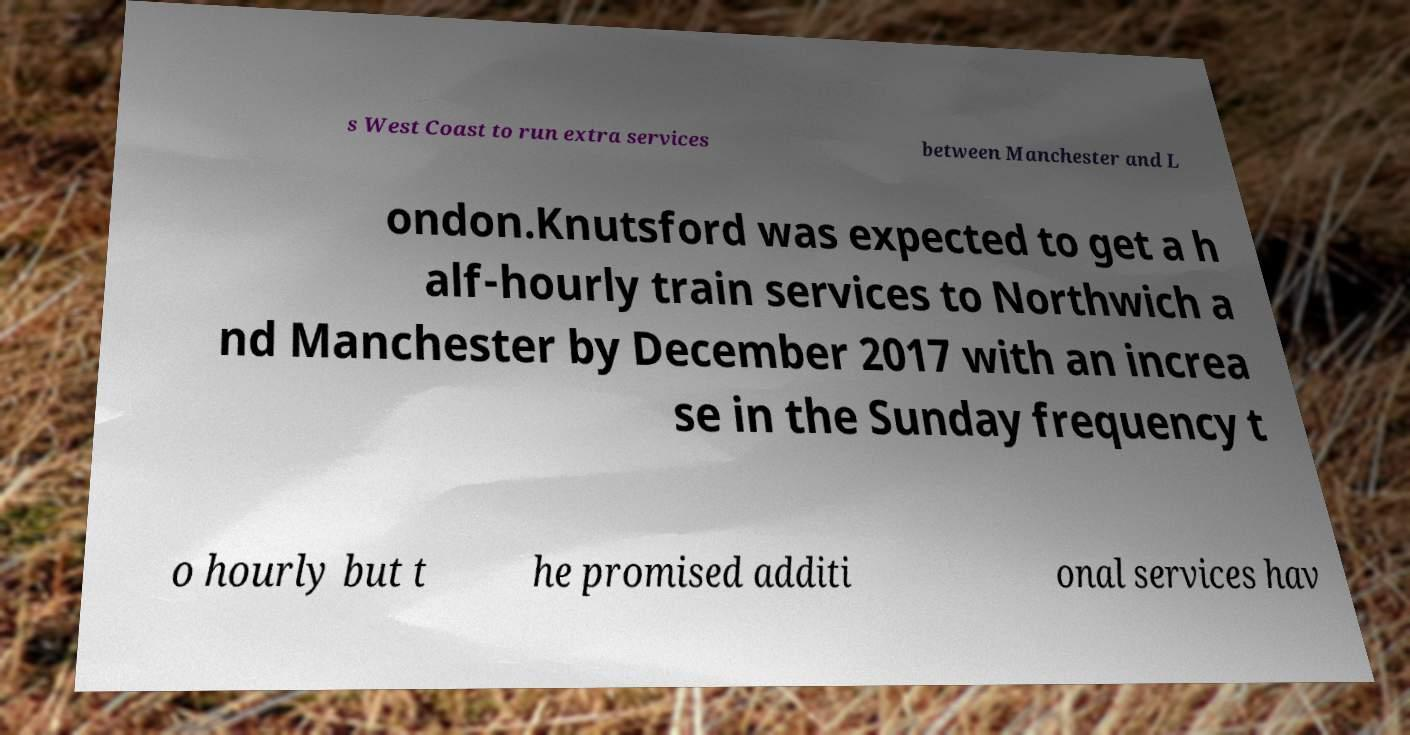For documentation purposes, I need the text within this image transcribed. Could you provide that? s West Coast to run extra services between Manchester and L ondon.Knutsford was expected to get a h alf-hourly train services to Northwich a nd Manchester by December 2017 with an increa se in the Sunday frequency t o hourly but t he promised additi onal services hav 